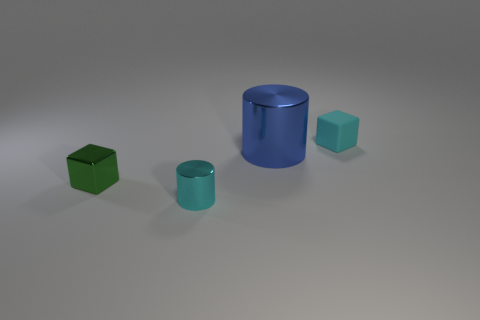What is the color of the small shiny block?
Provide a short and direct response. Green. Does the metal cube have the same color as the large cylinder?
Give a very brief answer. No. Are the tiny block that is to the left of the small cylinder and the cylinder that is behind the small green metallic object made of the same material?
Give a very brief answer. Yes. What material is the green object that is the same shape as the tiny cyan matte thing?
Give a very brief answer. Metal. Does the small cylinder have the same material as the blue thing?
Offer a terse response. Yes. There is a thing that is to the left of the metallic cylinder that is in front of the green object; what is its color?
Your response must be concise. Green. There is a blue object that is made of the same material as the green cube; what is its size?
Keep it short and to the point. Large. What number of other tiny matte things have the same shape as the green thing?
Provide a short and direct response. 1. What number of things are either cyan things that are right of the small metallic cylinder or small objects behind the big cylinder?
Make the answer very short. 1. How many big things are in front of the small cyan thing in front of the cyan block?
Offer a very short reply. 0. 